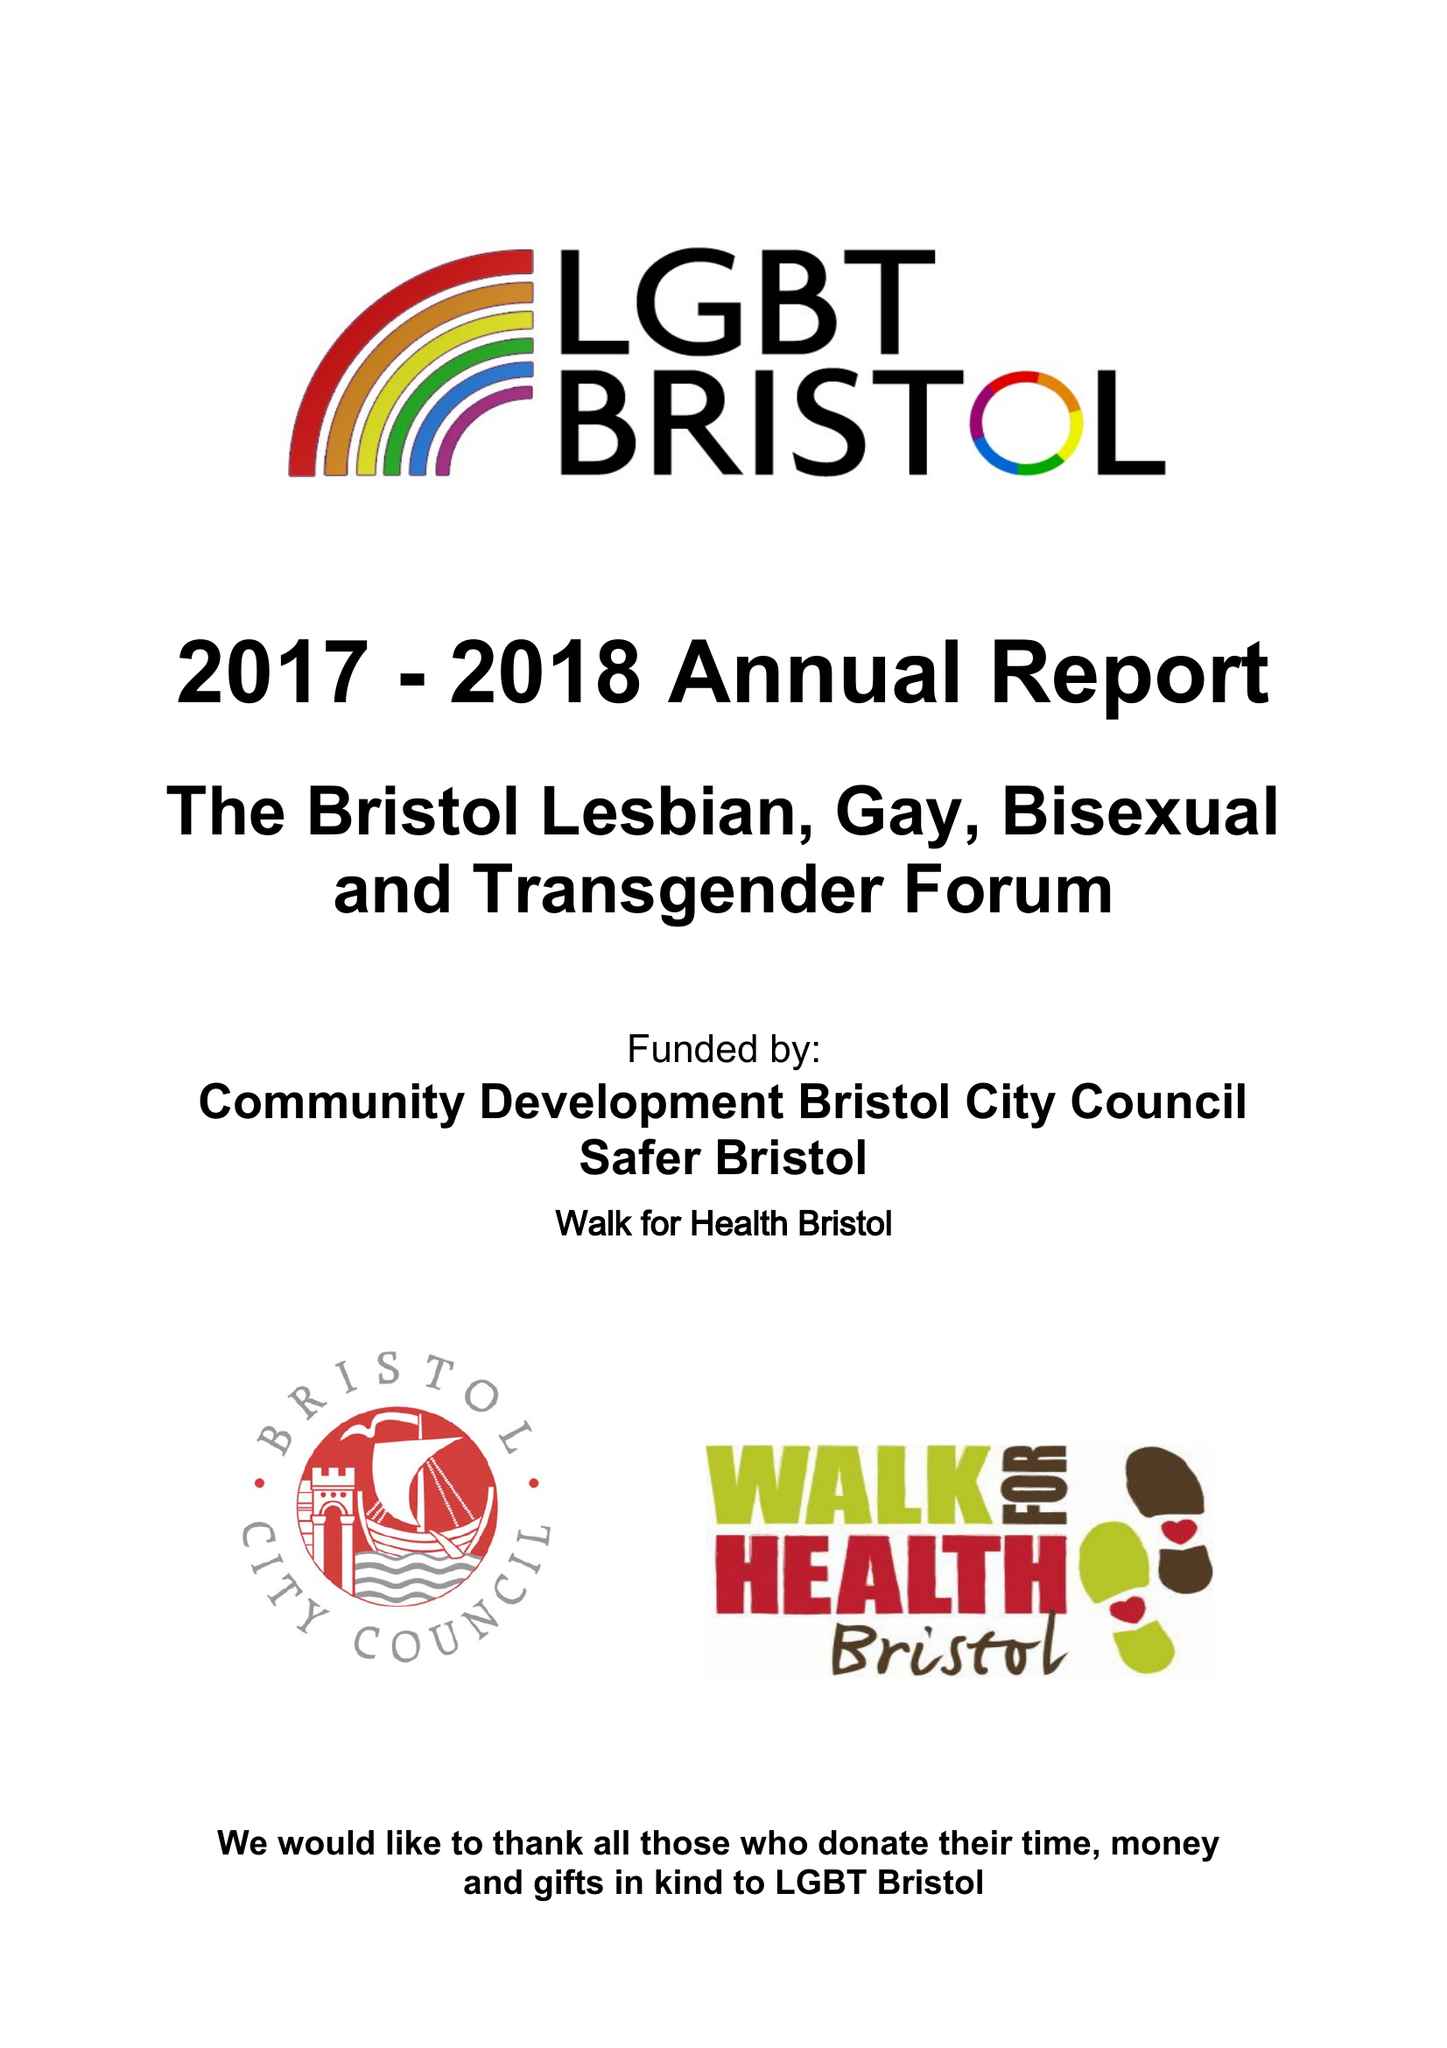What is the value for the charity_name?
Answer the question using a single word or phrase. Bristol Lesbian Gay Bisexual and Transgender Forum 